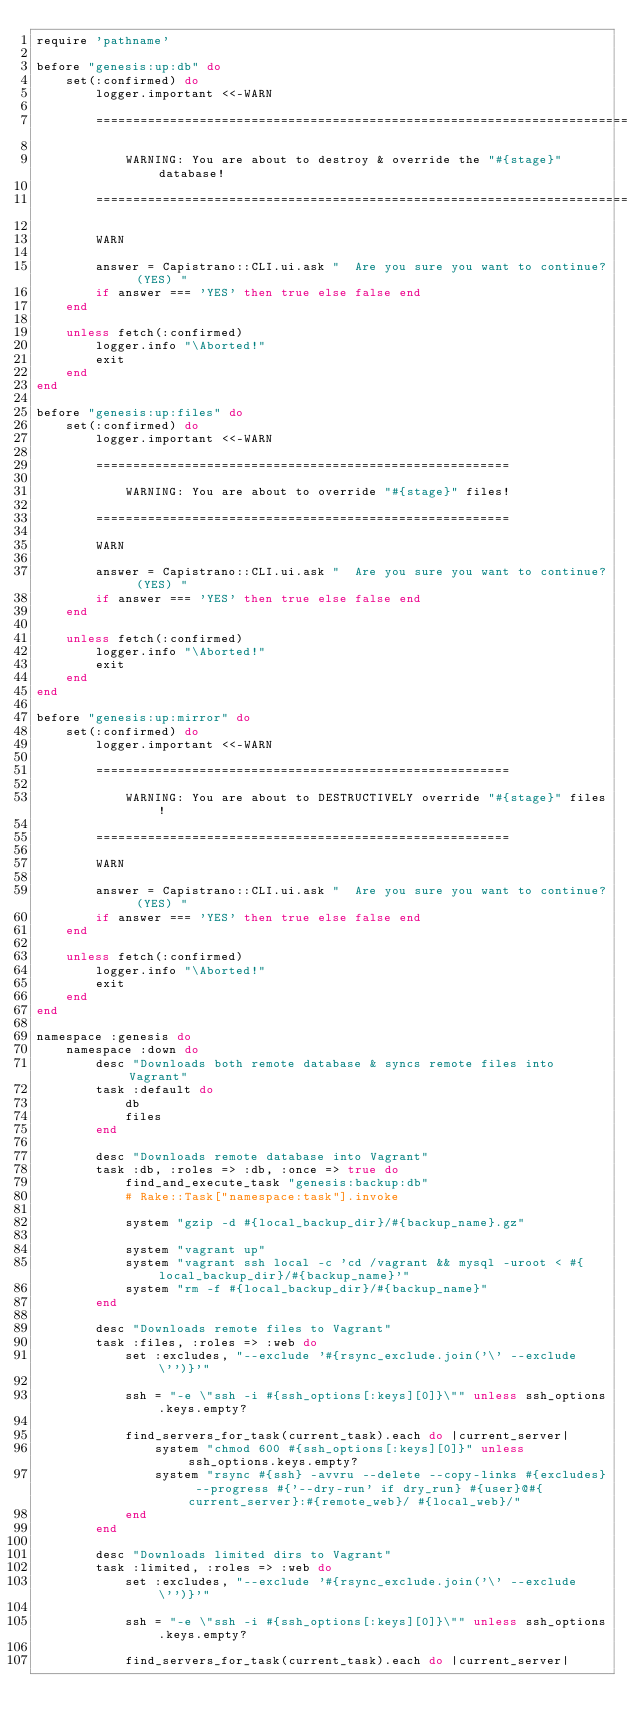Convert code to text. <code><loc_0><loc_0><loc_500><loc_500><_Ruby_>require 'pathname'

before "genesis:up:db" do
    set(:confirmed) do
        logger.important <<-WARN

        ========================================================================

            WARNING: You are about to destroy & override the "#{stage}" database!

        ========================================================================

        WARN

        answer = Capistrano::CLI.ui.ask "  Are you sure you want to continue? (YES) "
        if answer === 'YES' then true else false end
    end

    unless fetch(:confirmed)
        logger.info "\Aborted!"
        exit
    end
end

before "genesis:up:files" do
    set(:confirmed) do
        logger.important <<-WARN

        ========================================================

            WARNING: You are about to override "#{stage}" files!

        ========================================================

        WARN

        answer = Capistrano::CLI.ui.ask "  Are you sure you want to continue? (YES) "
        if answer === 'YES' then true else false end
    end

    unless fetch(:confirmed)
        logger.info "\Aborted!"
        exit
    end
end

before "genesis:up:mirror" do
    set(:confirmed) do
        logger.important <<-WARN

        ========================================================

            WARNING: You are about to DESTRUCTIVELY override "#{stage}" files!

        ========================================================

        WARN

        answer = Capistrano::CLI.ui.ask "  Are you sure you want to continue? (YES) "
        if answer === 'YES' then true else false end
    end

    unless fetch(:confirmed)
        logger.info "\Aborted!"
        exit
    end
end

namespace :genesis do
    namespace :down do
        desc "Downloads both remote database & syncs remote files into Vagrant"
        task :default do
            db
            files
        end

        desc "Downloads remote database into Vagrant"
        task :db, :roles => :db, :once => true do
            find_and_execute_task "genesis:backup:db"
            # Rake::Task["namespace:task"].invoke

            system "gzip -d #{local_backup_dir}/#{backup_name}.gz"

            system "vagrant up"
            system "vagrant ssh local -c 'cd /vagrant && mysql -uroot < #{local_backup_dir}/#{backup_name}'"
            system "rm -f #{local_backup_dir}/#{backup_name}"
        end

        desc "Downloads remote files to Vagrant"
        task :files, :roles => :web do
            set :excludes, "--exclude '#{rsync_exclude.join('\' --exclude \'')}'"

            ssh = "-e \"ssh -i #{ssh_options[:keys][0]}\"" unless ssh_options.keys.empty?

            find_servers_for_task(current_task).each do |current_server|
                system "chmod 600 #{ssh_options[:keys][0]}" unless ssh_options.keys.empty?
                system "rsync #{ssh} -avvru --delete --copy-links #{excludes} --progress #{'--dry-run' if dry_run} #{user}@#{current_server}:#{remote_web}/ #{local_web}/"
            end
        end

        desc "Downloads limited dirs to Vagrant"
        task :limited, :roles => :web do
            set :excludes, "--exclude '#{rsync_exclude.join('\' --exclude \'')}'"

            ssh = "-e \"ssh -i #{ssh_options[:keys][0]}\"" unless ssh_options.keys.empty?

            find_servers_for_task(current_task).each do |current_server|</code> 